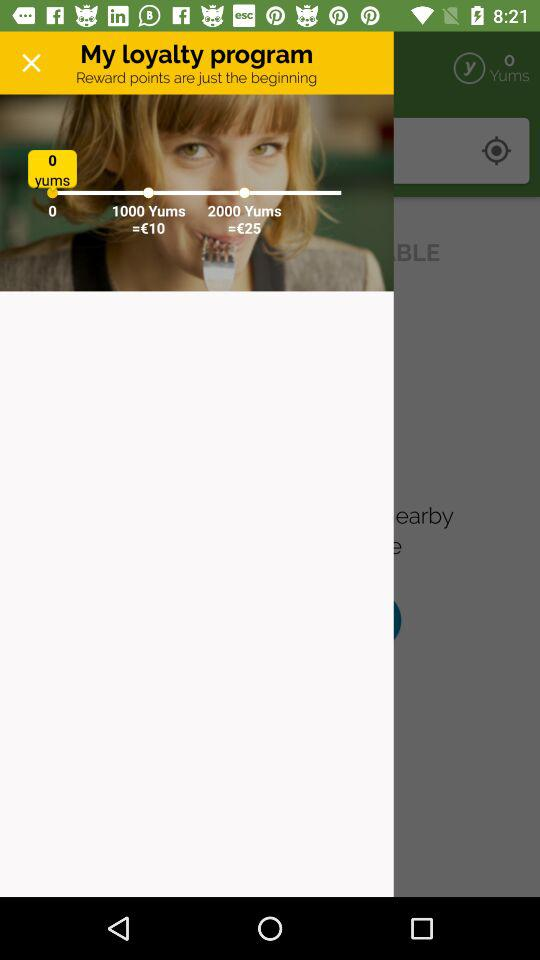How many Yums do I have?
Answer the question using a single word or phrase. 0 